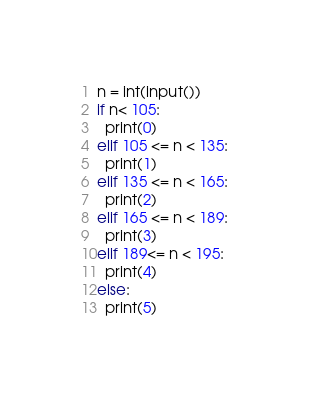<code> <loc_0><loc_0><loc_500><loc_500><_Python_>n = int(input())
if n< 105:
  print(0)
elif 105 <= n < 135:
  print(1)
elif 135 <= n < 165:
  print(2)
elif 165 <= n < 189:
  print(3)
elif 189<= n < 195:
  print(4)
else:
  print(5)</code> 